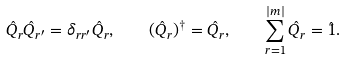Convert formula to latex. <formula><loc_0><loc_0><loc_500><loc_500>\hat { Q } _ { r } \hat { Q } _ { r ^ { \prime } } = \delta _ { r r ^ { \prime } } \hat { Q } _ { r } , \quad ( \hat { Q } _ { r } ) ^ { \dagger } = \hat { Q } _ { r } , \quad \sum _ { r = 1 } ^ { | m | } \hat { Q } _ { r } = \hat { 1 } .</formula> 